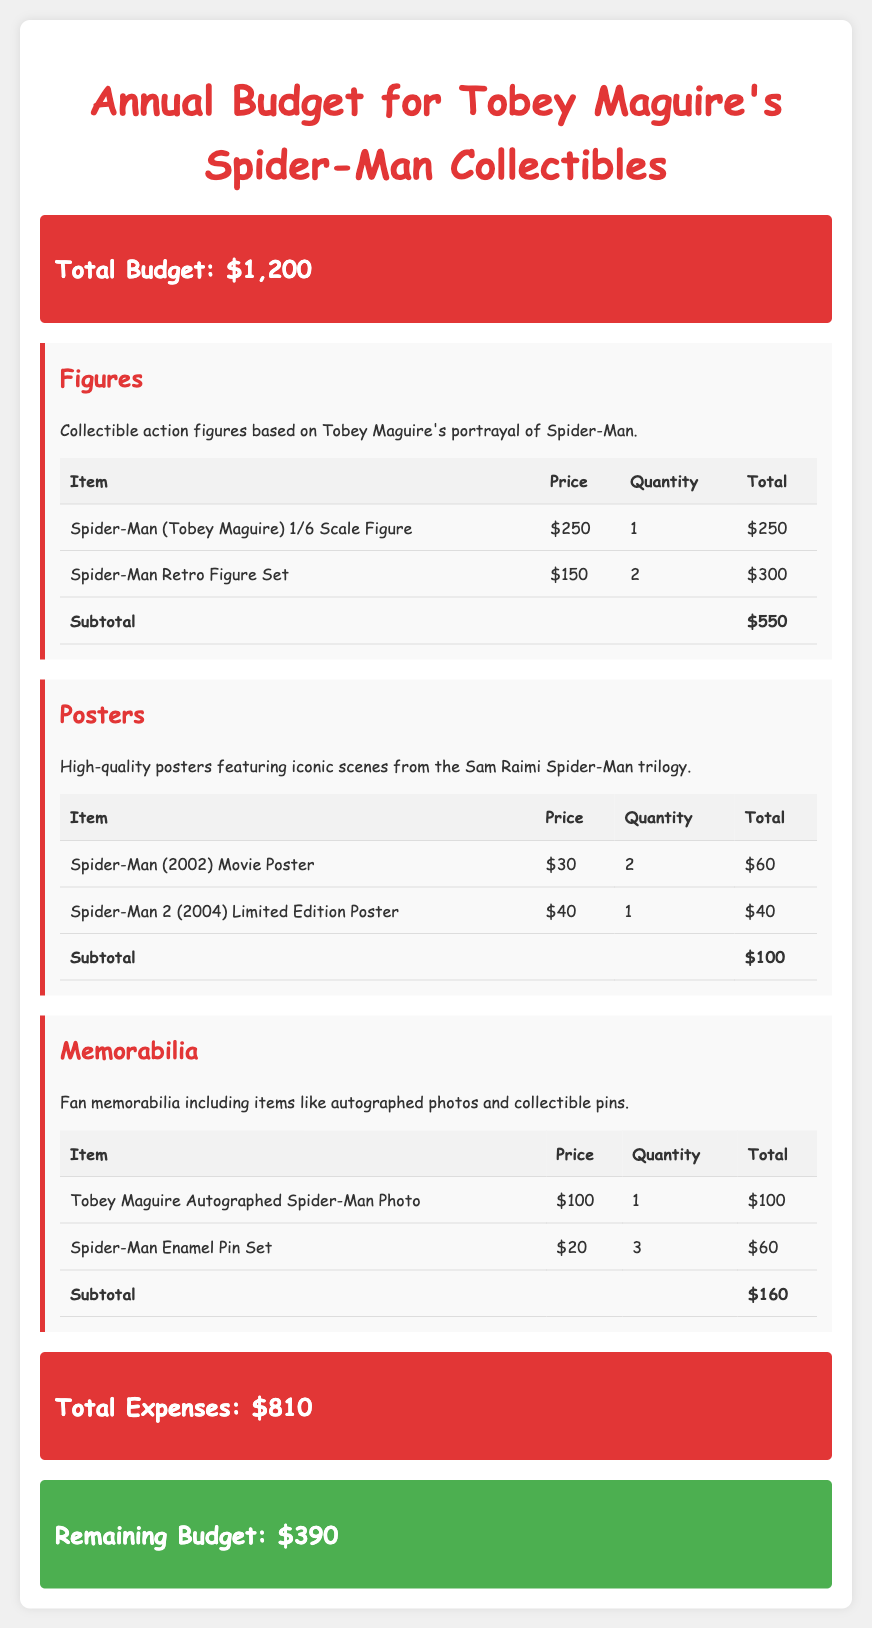What is the total budget? The total budget is stated at the beginning of the document, which summarizes the available funds for collectibles.
Answer: $1,200 How much is the Spider-Man (Tobey Maguire) 1/6 Scale Figure? The price of this specific collectible figure is listed in the figures section of the document.
Answer: $250 What is the subtotal for posters? The subtotal for the posters category is calculated from the prices listed in the poster table.
Answer: $100 How many Spider-Man Enamel Pins are purchased? The quantity of enamel pins is mentioned in the memorabilia section of the document.
Answer: 3 What is the remaining budget after expenses? The remaining budget is the total budget minus the total expenses, which is detailed in the budget summary.
Answer: $390 What is the total expense for all collectibles? The total expenses are summed up in the budget summary, which includes figures, posters, and memorabilia totals.
Answer: $810 How many types of collectibles are listed in the document? The document categorizes collectibles into figures, posters, and memorabilia, which total to three distinct types.
Answer: 3 What item has the highest price in the figures category? The highest priced item is determined by comparing the prices listed in the figures category table.
Answer: Spider-Man (Tobey Maguire) 1/6 Scale Figure How many Spider-Man (2002) Movie Posters are purchased? The quantity of this movie poster is stated in the posters table in the document.
Answer: 2 